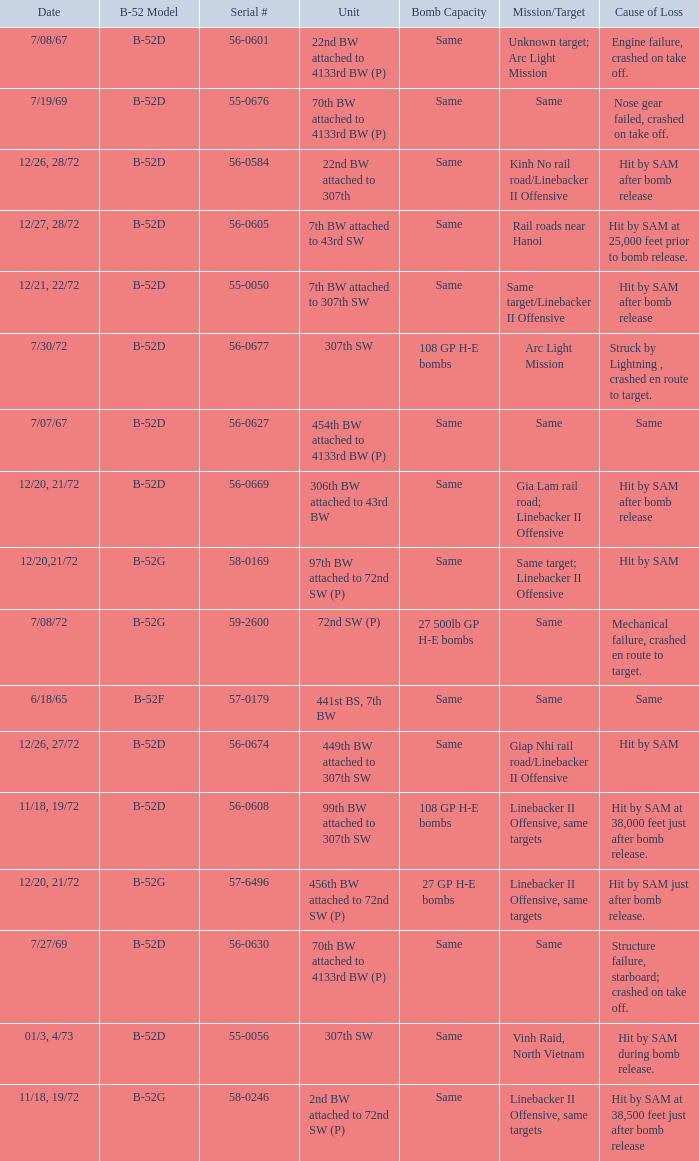When  27 gp h-e bombs the capacity of the bomb what is the cause of loss? Hit by SAM just after bomb release. 